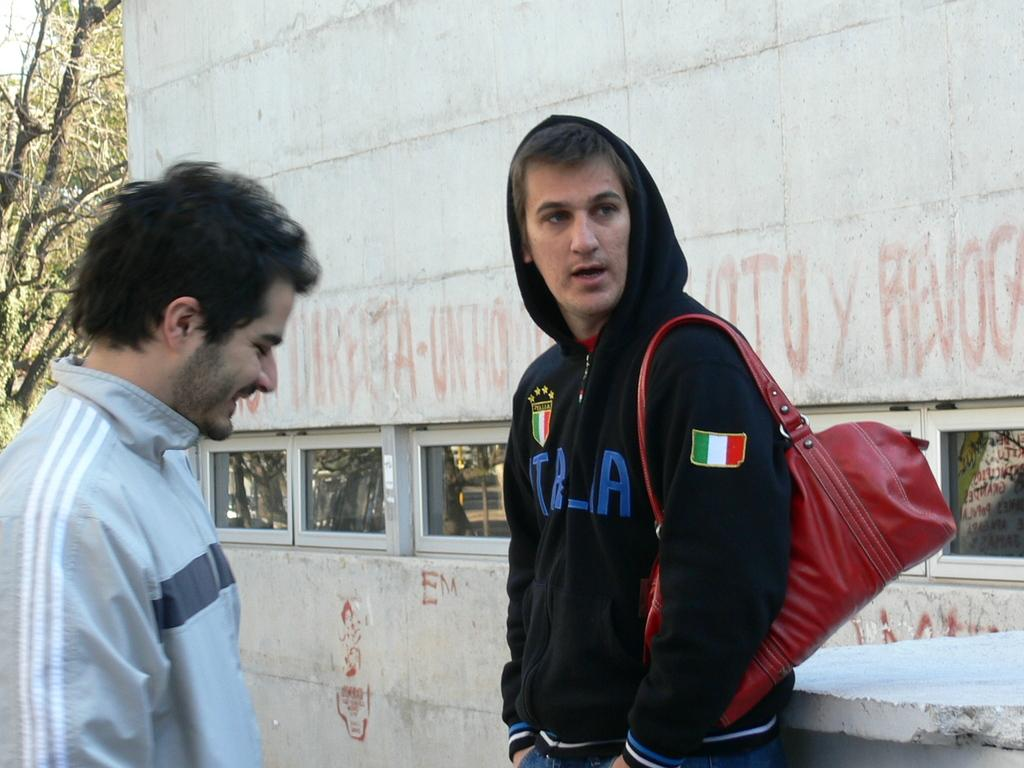<image>
Create a compact narrative representing the image presented. Man wearing a black sweater with the country Italy labeled on it. 